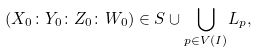<formula> <loc_0><loc_0><loc_500><loc_500>( X _ { 0 } \colon Y _ { 0 } \colon Z _ { 0 } \colon W _ { 0 } ) \in S \cup { \bigcup _ { p \in V ( I ) } } L _ { p } ,</formula> 